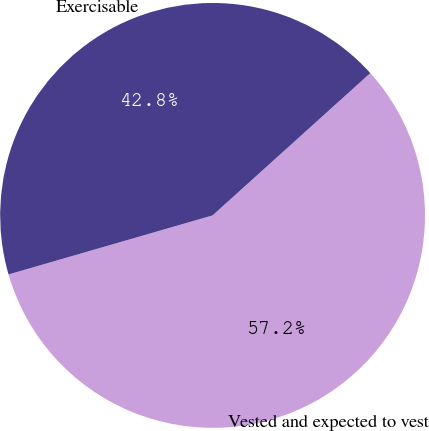Convert chart to OTSL. <chart><loc_0><loc_0><loc_500><loc_500><pie_chart><fcel>Vested and expected to vest<fcel>Exercisable<nl><fcel>57.2%<fcel>42.8%<nl></chart> 